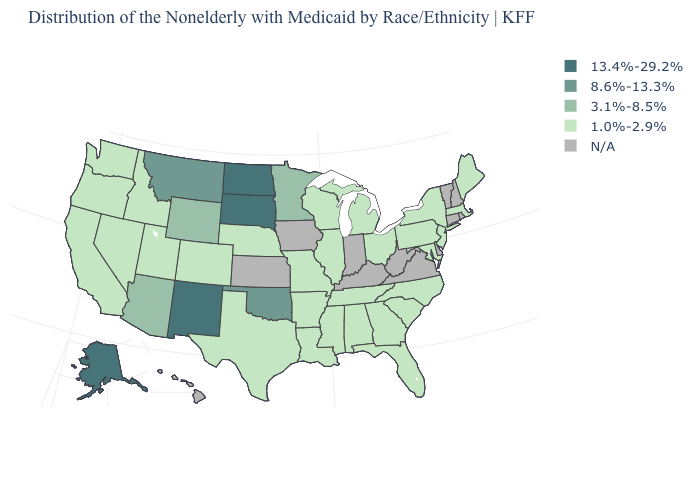What is the value of Colorado?
Write a very short answer. 1.0%-2.9%. What is the value of Texas?
Quick response, please. 1.0%-2.9%. Name the states that have a value in the range 3.1%-8.5%?
Short answer required. Arizona, Minnesota, Wyoming. Name the states that have a value in the range 8.6%-13.3%?
Quick response, please. Montana, Oklahoma. Does the map have missing data?
Write a very short answer. Yes. Does New Mexico have the highest value in the USA?
Quick response, please. Yes. Which states hav the highest value in the Northeast?
Be succinct. Maine, Massachusetts, New Jersey, New York, Pennsylvania. Which states have the highest value in the USA?
Be succinct. Alaska, New Mexico, North Dakota, South Dakota. Among the states that border Delaware , which have the highest value?
Keep it brief. Maryland, New Jersey, Pennsylvania. What is the highest value in the USA?
Answer briefly. 13.4%-29.2%. What is the value of Mississippi?
Answer briefly. 1.0%-2.9%. Does Texas have the lowest value in the USA?
Answer briefly. Yes. Does Oklahoma have the lowest value in the South?
Be succinct. No. 